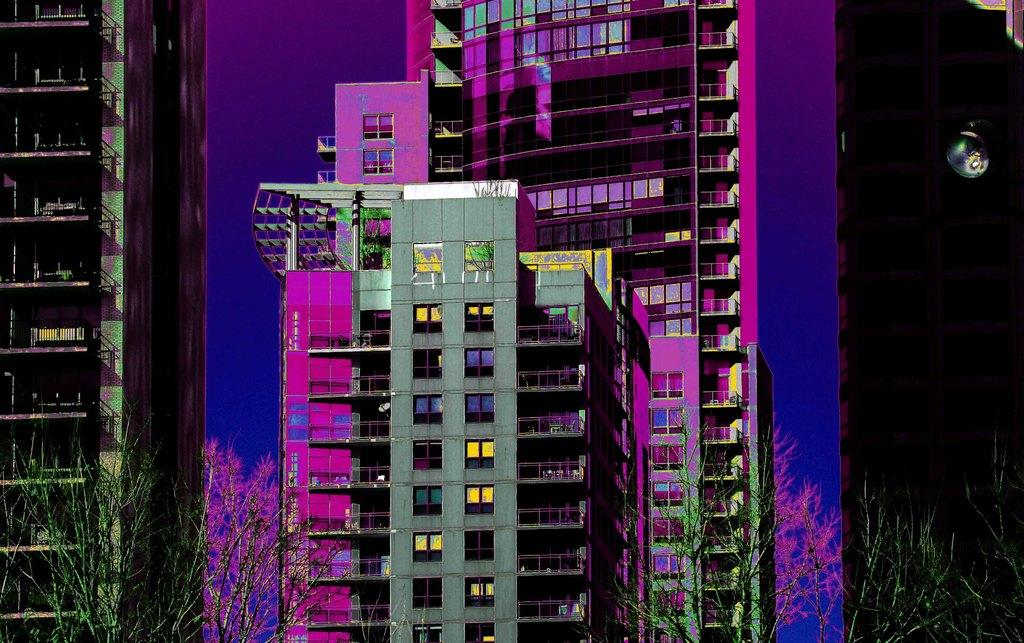What type of structures can be seen in the image? There are buildings in the image. What natural elements are present in the image? There are trees in the image. What architectural features can be observed in the image? There are walls and railings in the image. What song is being sung by the governor in the image? There is no governor or song present in the image. What type of fiction is depicted in the image? There is no fiction depicted in the image; it features buildings, trees, walls, and railings. 